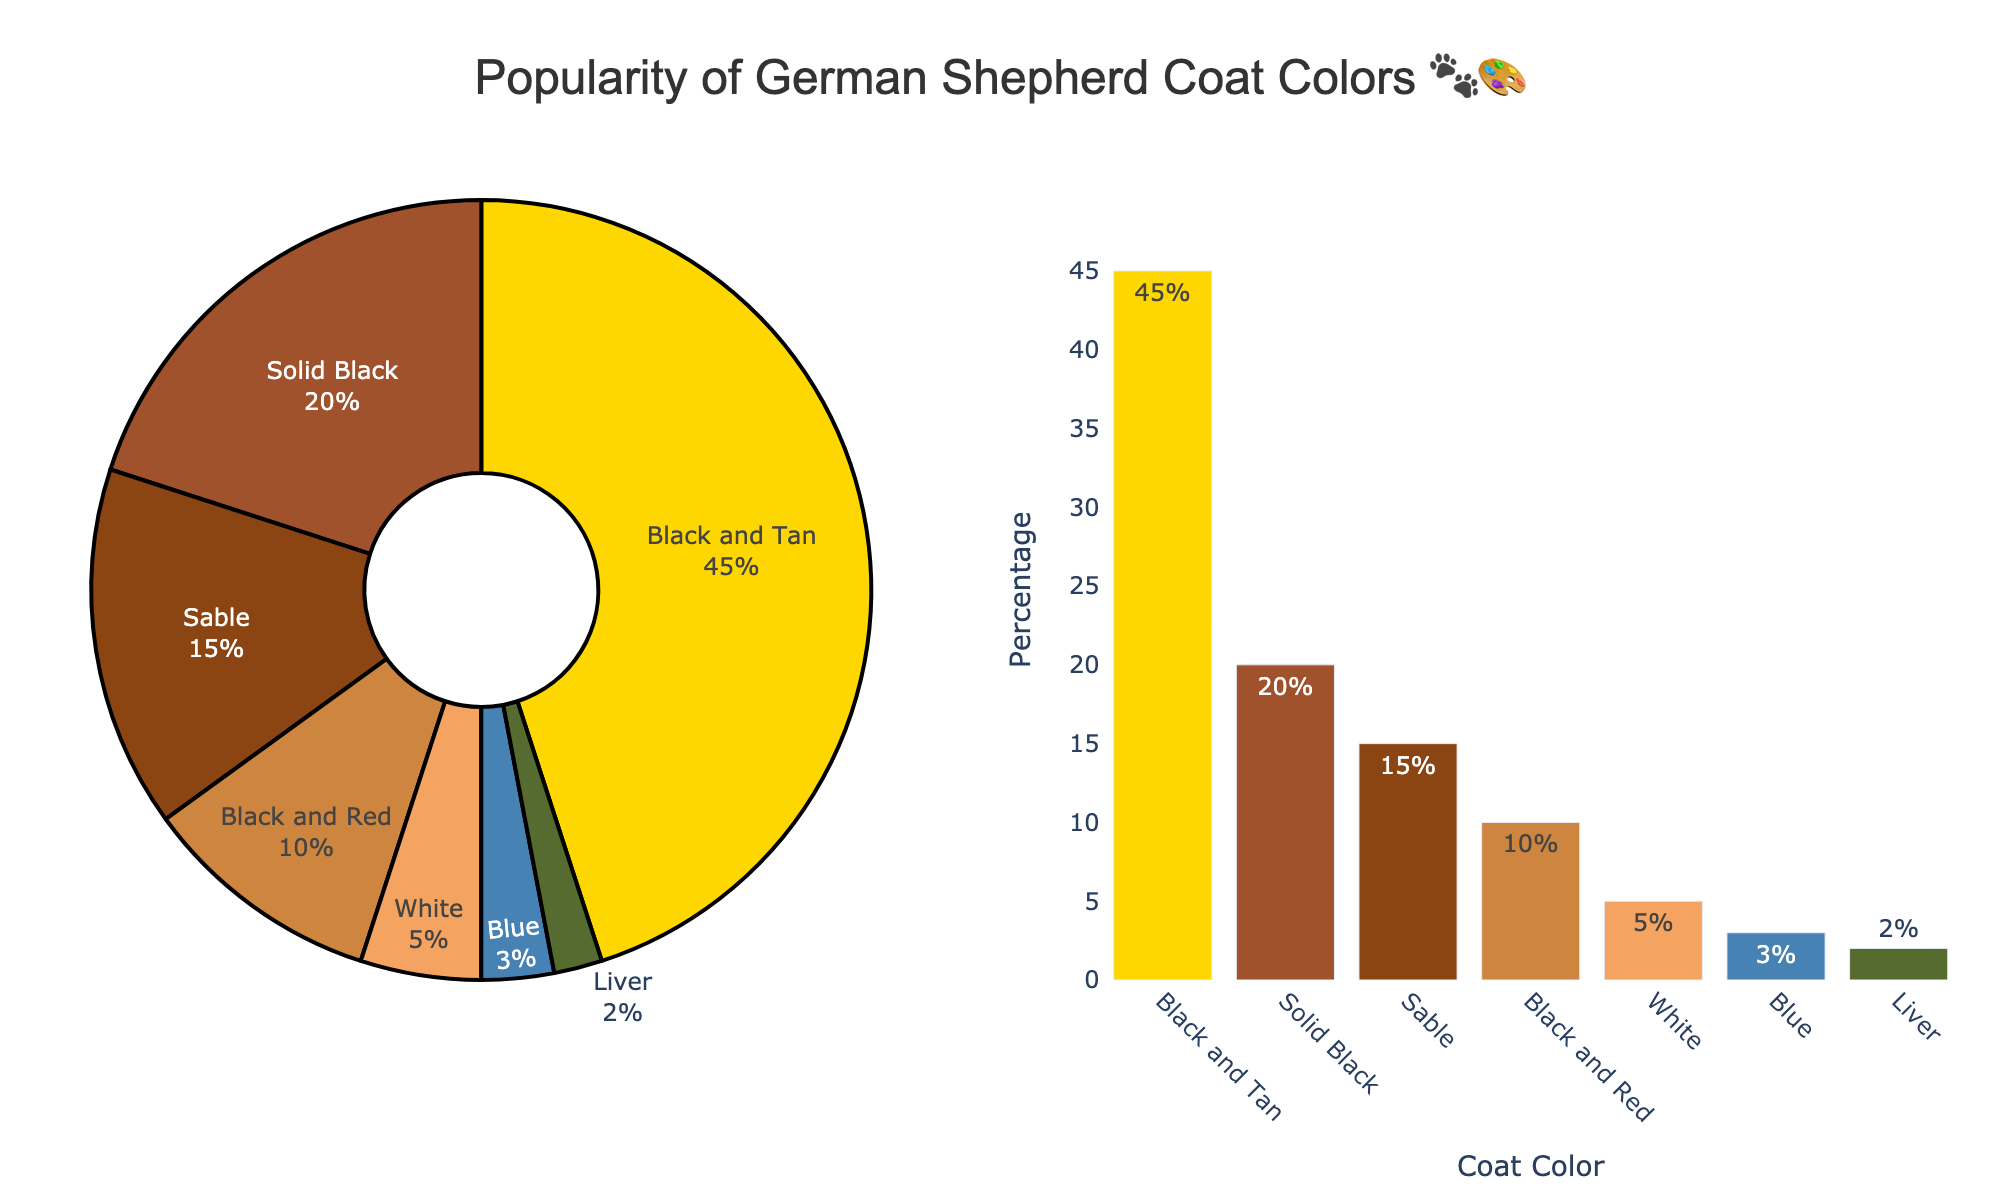What's the most popular German Shepherd coat color? The chart shows both a pie and bar chart, with the largest portion of the pie chart and tallest bar corresponding to the Black and Tan coat color, holding 45% popularity.
Answer: Black and Tan What's the percentage of German Shepherds with a Solid Black coat? Check the Solid Black section on the pie chart or its specific bar in the bar chart. The percentage value is given directly as 20%.
Answer: 20% What is the least common German Shepherd coat color? From the pie and bar charts, the smallest portion and shortest bar belong to the Liver coat color, which has a percentage of 2%.
Answer: Liver How much more popular is Black and Tan compared to Sable? Black and Tan has a 45% share, while Sable has a 15% share. Subtract the percentages to find the difference: 45% - 15% = 30%.
Answer: 30% What's the combined percentage of Black and Red and White coat colors? Look at the pie and bar chart where Black and Red is 10% and White is 5%. The combined percentage is the sum of these two values: 10% + 5% = 15%.
Answer: 15% Which coat color is three times as popular as the Blue coat color? According to the bar or pie chart, Blue is at 3%. To find three times this percentage, you get 3% * 3 = 9%. Comparing this percentage to the data, no coat color is exactly 9%, but closest higher one is Black and Red at 10%.
Answer: Black and Red What percentage of German Shepherds have either a White or Blue coat color? White has 5% and Blue has 3%. Adding these together gives: 5% + 3% = 8%.
Answer: 8% Which is more common, Sable or Black and Red? By how much? Sable is at 15% and Black and Red is at 10%. Subtract to see the difference: 15% - 10% = 5%.
Answer: Sable, by 5% What does the largest bar in the bar chart indicate? The largest bar represents the Black and Tan coat color with a percentage label of 45%.
Answer: Black and Tan with 45% How many coat colors have a popularity of less than 10%? Check the bar or pie chart and count the coat colors with bars or pie sections representing less than 10%; these are White, Blue, and Liver (5%, 3%, and 2%).
Answer: Three 